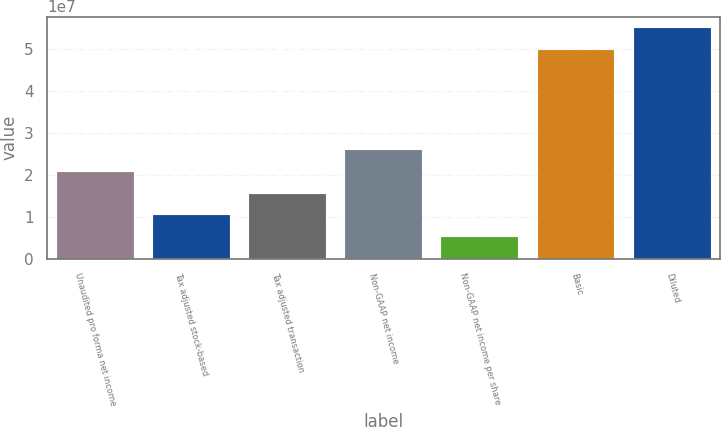<chart> <loc_0><loc_0><loc_500><loc_500><bar_chart><fcel>Unaudited pro forma net income<fcel>Tax adjusted stock-based<fcel>Tax adjusted transaction<fcel>Non-GAAP net income<fcel>Non-GAAP net income per share<fcel>Basic<fcel>Diluted<nl><fcel>2.07429e+07<fcel>1.03715e+07<fcel>1.55572e+07<fcel>2.59287e+07<fcel>5.18573e+06<fcel>4.97842e+07<fcel>5.49699e+07<nl></chart> 